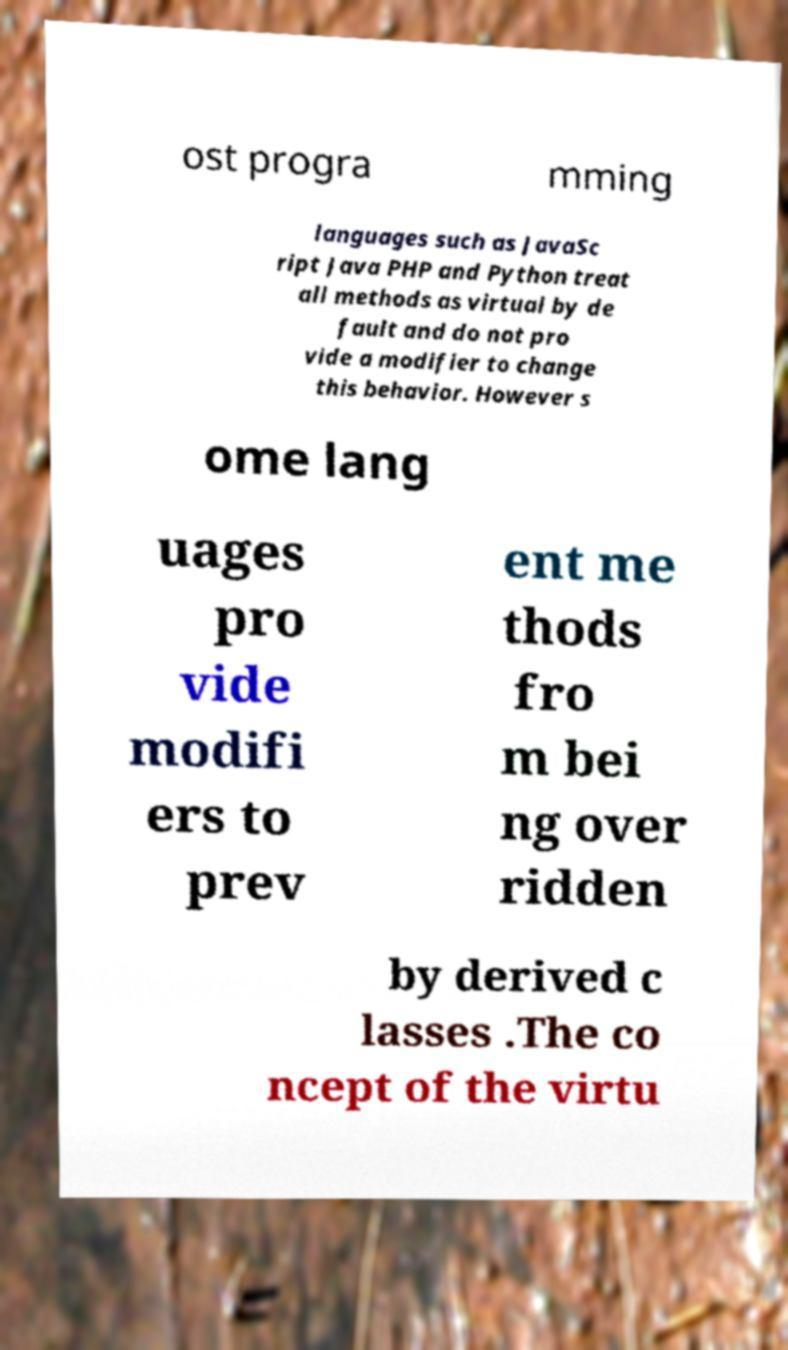Please identify and transcribe the text found in this image. ost progra mming languages such as JavaSc ript Java PHP and Python treat all methods as virtual by de fault and do not pro vide a modifier to change this behavior. However s ome lang uages pro vide modifi ers to prev ent me thods fro m bei ng over ridden by derived c lasses .The co ncept of the virtu 